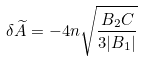Convert formula to latex. <formula><loc_0><loc_0><loc_500><loc_500>\delta \widetilde { A } = - 4 n \sqrt { \frac { B _ { 2 } C } { 3 | B _ { 1 } | } }</formula> 